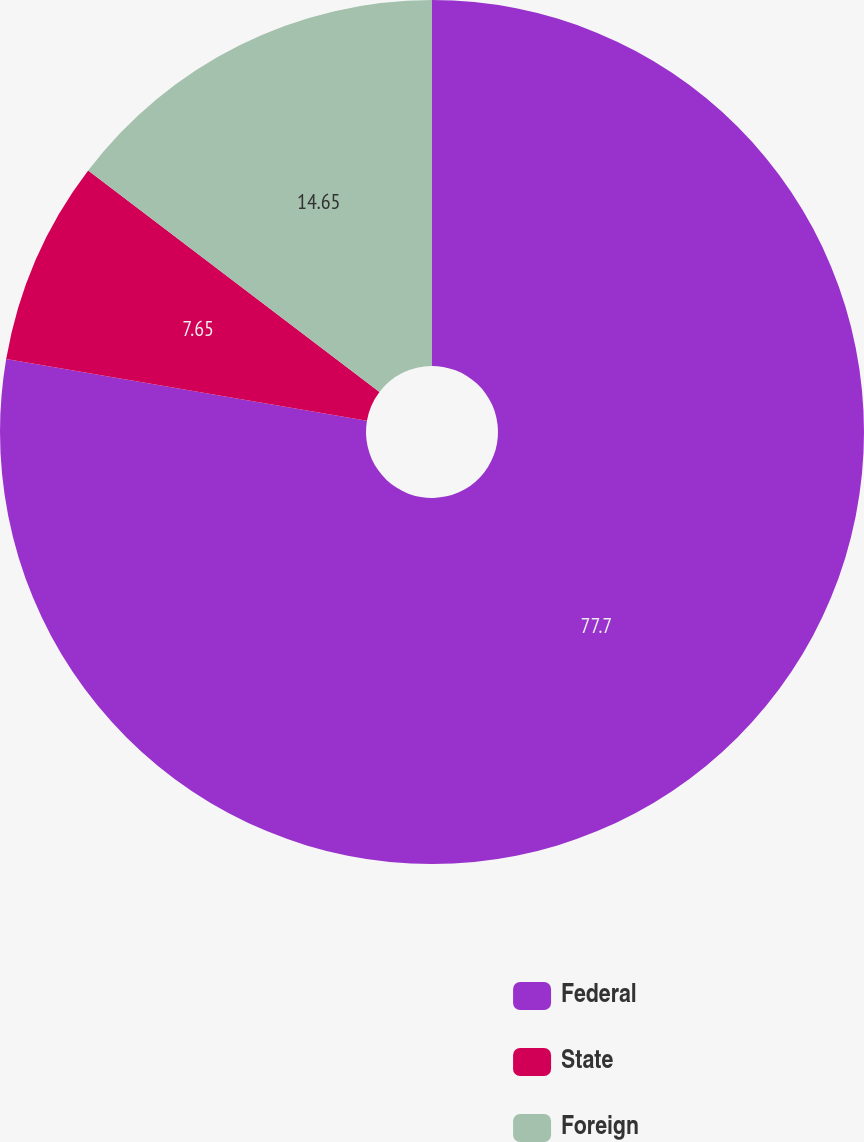Convert chart. <chart><loc_0><loc_0><loc_500><loc_500><pie_chart><fcel>Federal<fcel>State<fcel>Foreign<nl><fcel>77.7%<fcel>7.65%<fcel>14.65%<nl></chart> 